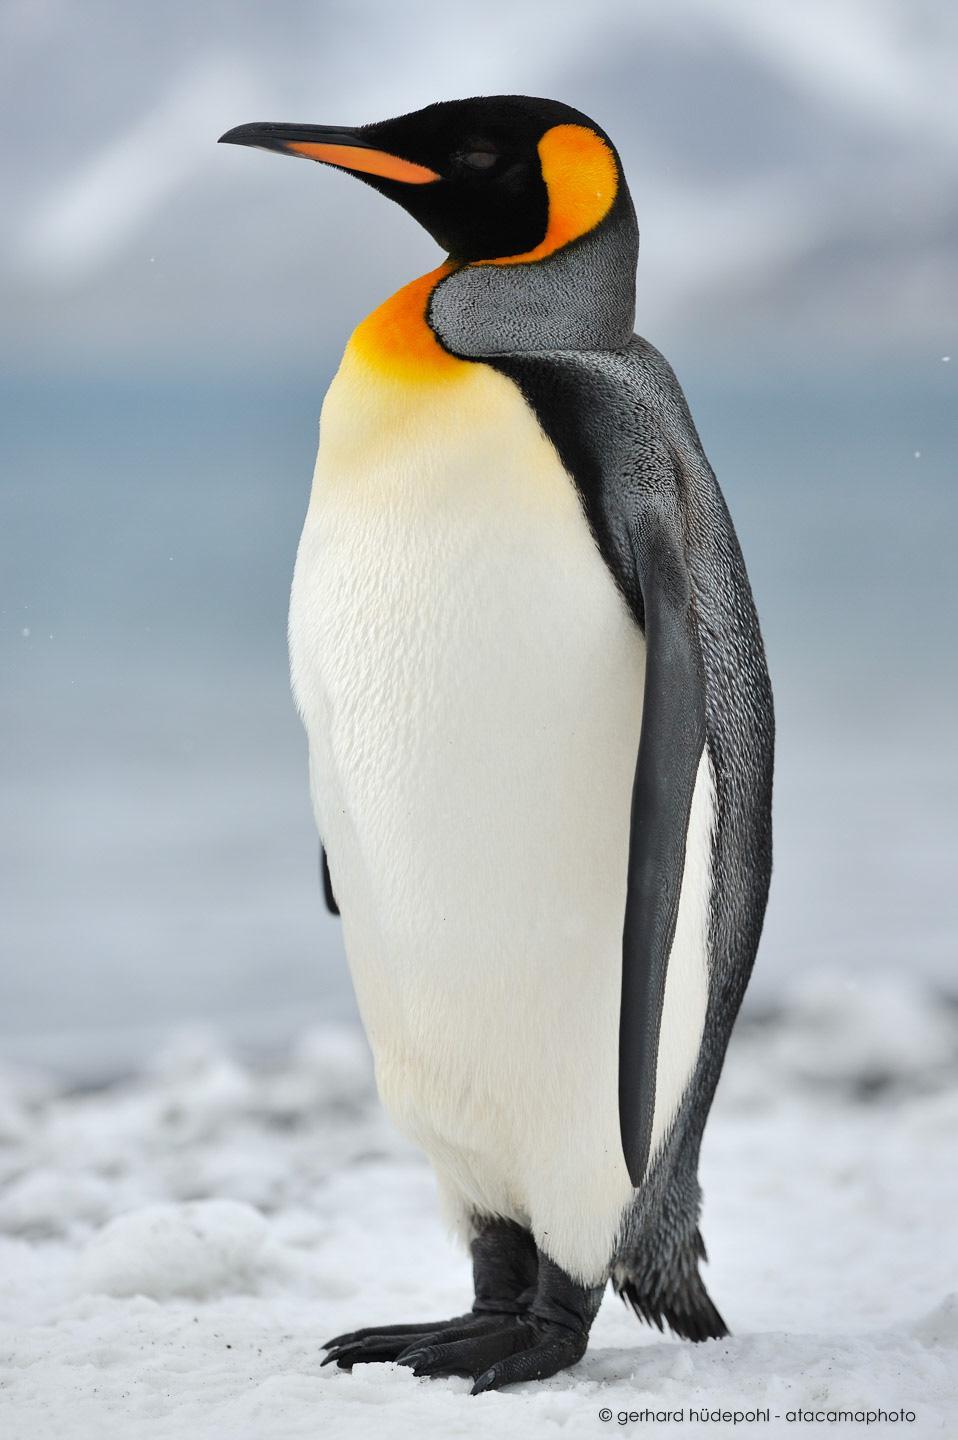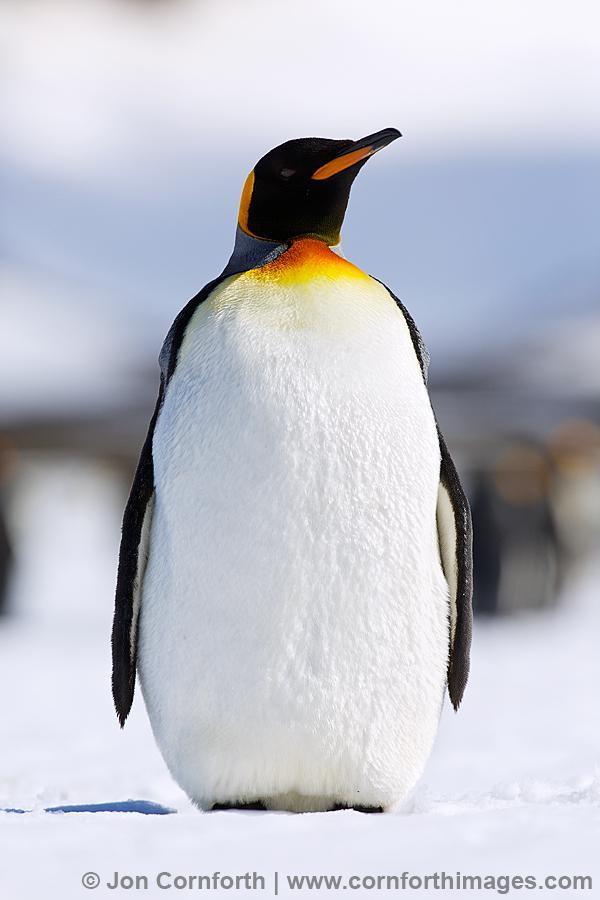The first image is the image on the left, the second image is the image on the right. For the images shown, is this caption "One image shows a single adult penguin, standing on snow and facing left." true? Answer yes or no. Yes. 